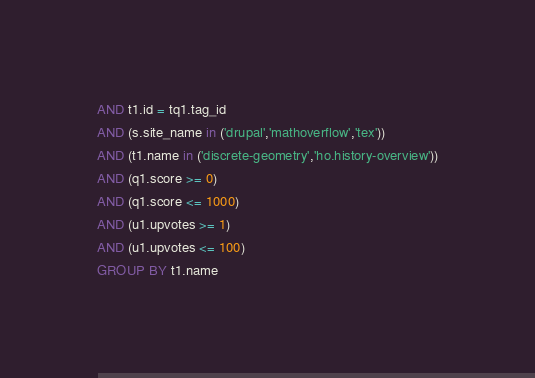Convert code to text. <code><loc_0><loc_0><loc_500><loc_500><_SQL_>AND t1.id = tq1.tag_id
AND (s.site_name in ('drupal','mathoverflow','tex'))
AND (t1.name in ('discrete-geometry','ho.history-overview'))
AND (q1.score >= 0)
AND (q1.score <= 1000)
AND (u1.upvotes >= 1)
AND (u1.upvotes <= 100)
GROUP BY t1.name</code> 